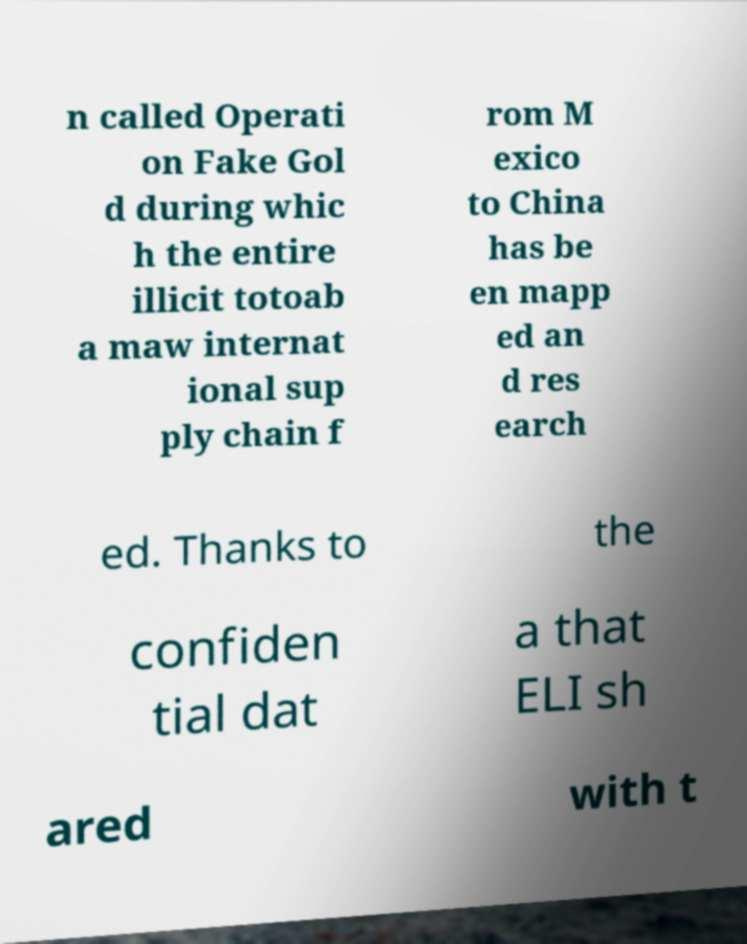There's text embedded in this image that I need extracted. Can you transcribe it verbatim? n called Operati on Fake Gol d during whic h the entire illicit totoab a maw internat ional sup ply chain f rom M exico to China has be en mapp ed an d res earch ed. Thanks to the confiden tial dat a that ELI sh ared with t 